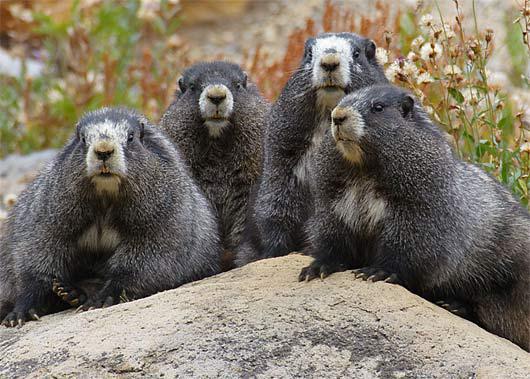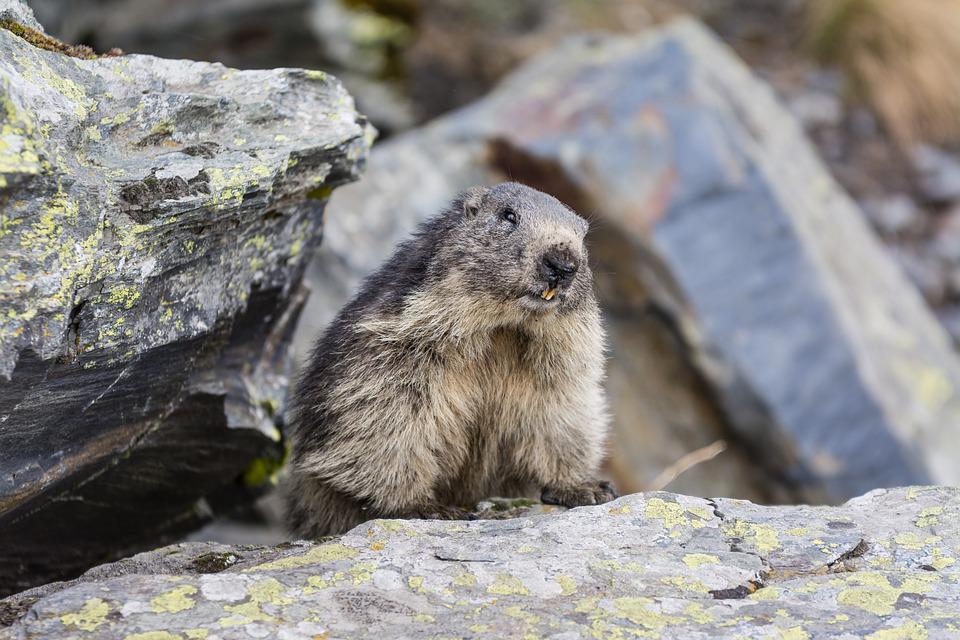The first image is the image on the left, the second image is the image on the right. Evaluate the accuracy of this statement regarding the images: "There are no more than two rodents.". Is it true? Answer yes or no. No. The first image is the image on the left, the second image is the image on the right. Examine the images to the left and right. Is the description "The animal is facing left in the left image and right in the right image." accurate? Answer yes or no. No. 